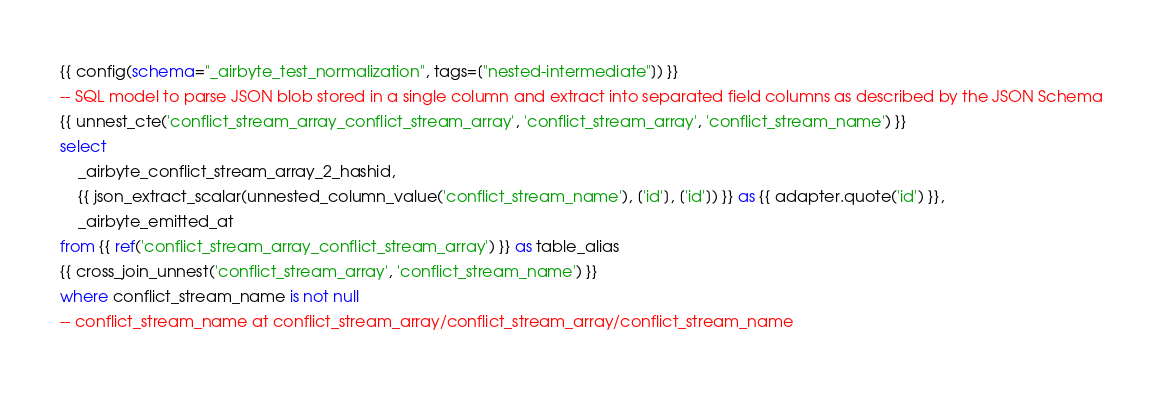Convert code to text. <code><loc_0><loc_0><loc_500><loc_500><_SQL_>{{ config(schema="_airbyte_test_normalization", tags=["nested-intermediate"]) }}
-- SQL model to parse JSON blob stored in a single column and extract into separated field columns as described by the JSON Schema
{{ unnest_cte('conflict_stream_array_conflict_stream_array', 'conflict_stream_array', 'conflict_stream_name') }}
select
    _airbyte_conflict_stream_array_2_hashid,
    {{ json_extract_scalar(unnested_column_value('conflict_stream_name'), ['id'], ['id']) }} as {{ adapter.quote('id') }},
    _airbyte_emitted_at
from {{ ref('conflict_stream_array_conflict_stream_array') }} as table_alias
{{ cross_join_unnest('conflict_stream_array', 'conflict_stream_name') }}
where conflict_stream_name is not null
-- conflict_stream_name at conflict_stream_array/conflict_stream_array/conflict_stream_name

</code> 